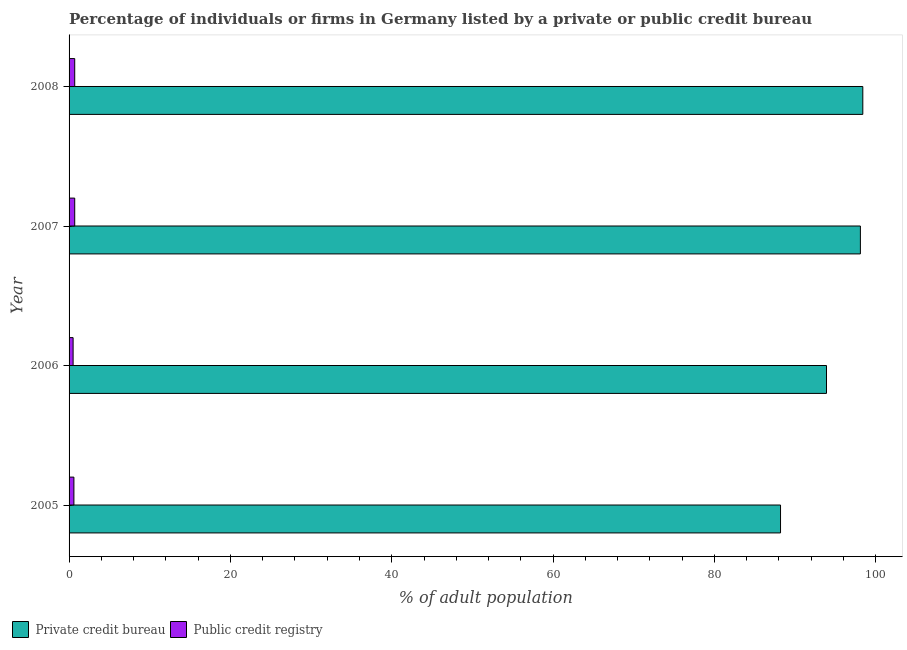How many groups of bars are there?
Offer a terse response. 4. How many bars are there on the 3rd tick from the top?
Make the answer very short. 2. How many bars are there on the 4th tick from the bottom?
Your answer should be compact. 2. What is the label of the 1st group of bars from the top?
Your response must be concise. 2008. Across all years, what is the maximum percentage of firms listed by private credit bureau?
Provide a succinct answer. 98.4. Across all years, what is the minimum percentage of firms listed by public credit bureau?
Your response must be concise. 0.5. In which year was the percentage of firms listed by private credit bureau maximum?
Offer a very short reply. 2008. What is the difference between the percentage of firms listed by private credit bureau in 2007 and the percentage of firms listed by public credit bureau in 2006?
Offer a terse response. 97.6. What is the average percentage of firms listed by private credit bureau per year?
Offer a terse response. 94.65. In the year 2005, what is the difference between the percentage of firms listed by public credit bureau and percentage of firms listed by private credit bureau?
Provide a succinct answer. -87.6. In how many years, is the percentage of firms listed by public credit bureau greater than 36 %?
Make the answer very short. 0. What is the ratio of the percentage of firms listed by private credit bureau in 2005 to that in 2008?
Provide a succinct answer. 0.9. Is the percentage of firms listed by public credit bureau in 2007 less than that in 2008?
Give a very brief answer. No. What is the difference between the highest and the second highest percentage of firms listed by private credit bureau?
Ensure brevity in your answer.  0.3. What is the difference between the highest and the lowest percentage of firms listed by private credit bureau?
Keep it short and to the point. 10.2. In how many years, is the percentage of firms listed by private credit bureau greater than the average percentage of firms listed by private credit bureau taken over all years?
Provide a succinct answer. 2. What does the 2nd bar from the top in 2007 represents?
Offer a very short reply. Private credit bureau. What does the 2nd bar from the bottom in 2005 represents?
Give a very brief answer. Public credit registry. Does the graph contain any zero values?
Your answer should be very brief. No. Where does the legend appear in the graph?
Provide a succinct answer. Bottom left. How many legend labels are there?
Provide a succinct answer. 2. How are the legend labels stacked?
Provide a succinct answer. Horizontal. What is the title of the graph?
Provide a short and direct response. Percentage of individuals or firms in Germany listed by a private or public credit bureau. Does "Under-five" appear as one of the legend labels in the graph?
Keep it short and to the point. No. What is the label or title of the X-axis?
Offer a very short reply. % of adult population. What is the % of adult population in Private credit bureau in 2005?
Offer a terse response. 88.2. What is the % of adult population in Public credit registry in 2005?
Give a very brief answer. 0.6. What is the % of adult population in Private credit bureau in 2006?
Give a very brief answer. 93.9. What is the % of adult population of Private credit bureau in 2007?
Your answer should be compact. 98.1. What is the % of adult population of Private credit bureau in 2008?
Keep it short and to the point. 98.4. Across all years, what is the maximum % of adult population of Private credit bureau?
Your answer should be very brief. 98.4. Across all years, what is the maximum % of adult population in Public credit registry?
Provide a short and direct response. 0.7. Across all years, what is the minimum % of adult population in Private credit bureau?
Your response must be concise. 88.2. What is the total % of adult population in Private credit bureau in the graph?
Give a very brief answer. 378.6. What is the total % of adult population of Public credit registry in the graph?
Your response must be concise. 2.5. What is the difference between the % of adult population in Private credit bureau in 2005 and that in 2007?
Provide a succinct answer. -9.9. What is the difference between the % of adult population of Public credit registry in 2005 and that in 2007?
Your answer should be very brief. -0.1. What is the difference between the % of adult population in Private credit bureau in 2005 and that in 2008?
Provide a short and direct response. -10.2. What is the difference between the % of adult population in Public credit registry in 2006 and that in 2007?
Your answer should be very brief. -0.2. What is the difference between the % of adult population in Private credit bureau in 2006 and that in 2008?
Offer a terse response. -4.5. What is the difference between the % of adult population in Private credit bureau in 2005 and the % of adult population in Public credit registry in 2006?
Give a very brief answer. 87.7. What is the difference between the % of adult population in Private credit bureau in 2005 and the % of adult population in Public credit registry in 2007?
Give a very brief answer. 87.5. What is the difference between the % of adult population of Private credit bureau in 2005 and the % of adult population of Public credit registry in 2008?
Provide a succinct answer. 87.5. What is the difference between the % of adult population in Private credit bureau in 2006 and the % of adult population in Public credit registry in 2007?
Provide a short and direct response. 93.2. What is the difference between the % of adult population of Private credit bureau in 2006 and the % of adult population of Public credit registry in 2008?
Your answer should be very brief. 93.2. What is the difference between the % of adult population of Private credit bureau in 2007 and the % of adult population of Public credit registry in 2008?
Ensure brevity in your answer.  97.4. What is the average % of adult population of Private credit bureau per year?
Your answer should be very brief. 94.65. What is the average % of adult population of Public credit registry per year?
Provide a succinct answer. 0.62. In the year 2005, what is the difference between the % of adult population in Private credit bureau and % of adult population in Public credit registry?
Keep it short and to the point. 87.6. In the year 2006, what is the difference between the % of adult population in Private credit bureau and % of adult population in Public credit registry?
Make the answer very short. 93.4. In the year 2007, what is the difference between the % of adult population of Private credit bureau and % of adult population of Public credit registry?
Your answer should be compact. 97.4. In the year 2008, what is the difference between the % of adult population of Private credit bureau and % of adult population of Public credit registry?
Your answer should be very brief. 97.7. What is the ratio of the % of adult population in Private credit bureau in 2005 to that in 2006?
Keep it short and to the point. 0.94. What is the ratio of the % of adult population of Public credit registry in 2005 to that in 2006?
Ensure brevity in your answer.  1.2. What is the ratio of the % of adult population in Private credit bureau in 2005 to that in 2007?
Offer a very short reply. 0.9. What is the ratio of the % of adult population in Private credit bureau in 2005 to that in 2008?
Keep it short and to the point. 0.9. What is the ratio of the % of adult population in Private credit bureau in 2006 to that in 2007?
Ensure brevity in your answer.  0.96. What is the ratio of the % of adult population of Public credit registry in 2006 to that in 2007?
Ensure brevity in your answer.  0.71. What is the ratio of the % of adult population in Private credit bureau in 2006 to that in 2008?
Your answer should be compact. 0.95. What is the ratio of the % of adult population in Private credit bureau in 2007 to that in 2008?
Make the answer very short. 1. What is the difference between the highest and the second highest % of adult population in Public credit registry?
Provide a succinct answer. 0. What is the difference between the highest and the lowest % of adult population of Public credit registry?
Ensure brevity in your answer.  0.2. 